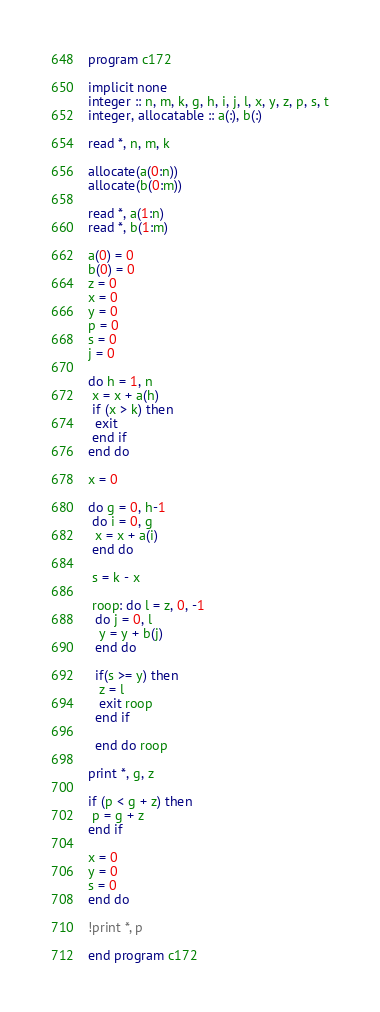<code> <loc_0><loc_0><loc_500><loc_500><_FORTRAN_>program c172
 
implicit none
integer :: n, m, k, g, h, i, j, l, x, y, z, p, s, t
integer, allocatable :: a(:), b(:)

read *, n, m, k
 
allocate(a(0:n))
allocate(b(0:m))
 
read *, a(1:n)
read *, b(1:m)

a(0) = 0
b(0) = 0
z = 0
x = 0
y = 0
p = 0
s = 0
j = 0

do h = 1, n
 x = x + a(h)
 if (x > k) then
  exit
 end if
end do

x = 0

do g = 0, h-1
 do i = 0, g
  x = x + a(i)
 end do
 
 s = k - x
 
 roop: do l = z, 0, -1
  do j = 0, l
   y = y + b(j)
  end do
  
  if(s >= y) then
   z = l
   exit roop
  end if
   
  end do roop

print *, g, z

if (p < g + z) then
 p = g + z
end if

x = 0
y = 0
s = 0
end do

!print *, p
 
end program c172</code> 